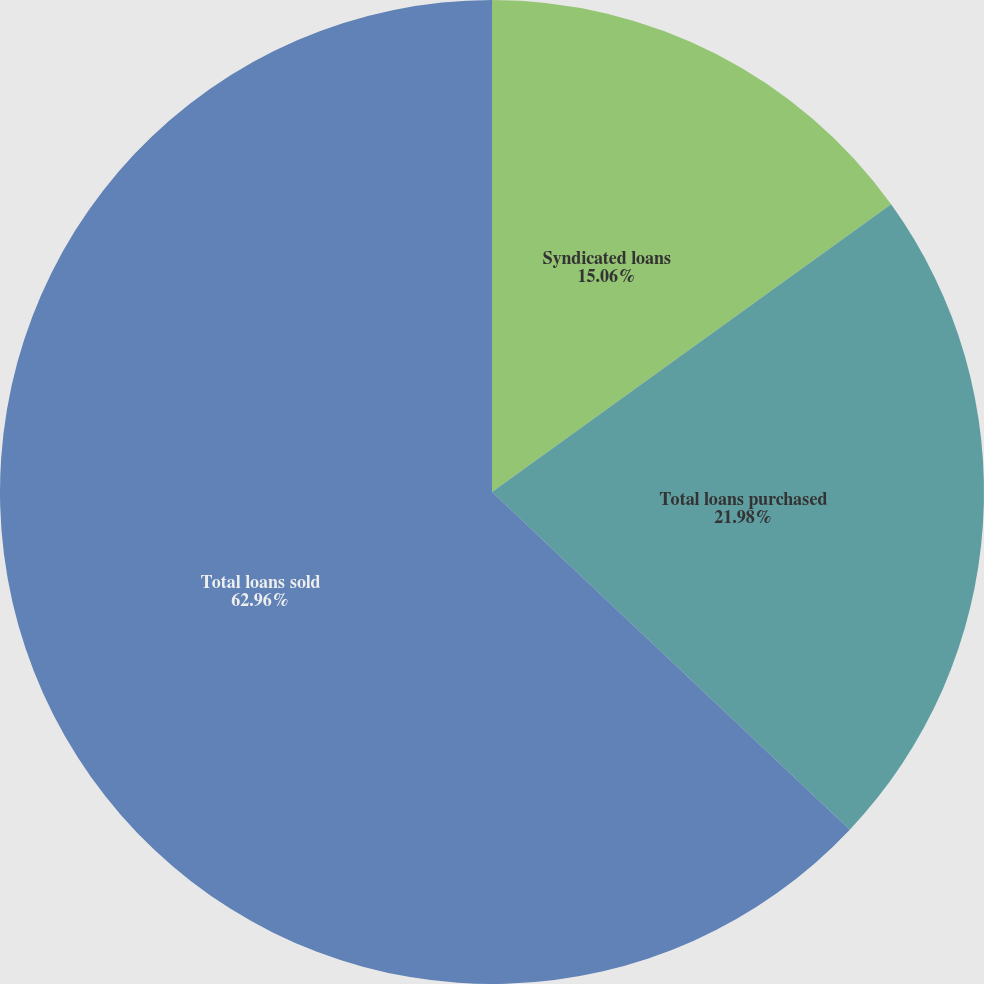Convert chart. <chart><loc_0><loc_0><loc_500><loc_500><pie_chart><fcel>Syndicated loans<fcel>Total loans purchased<fcel>Total loans sold<nl><fcel>15.06%<fcel>21.98%<fcel>62.96%<nl></chart> 